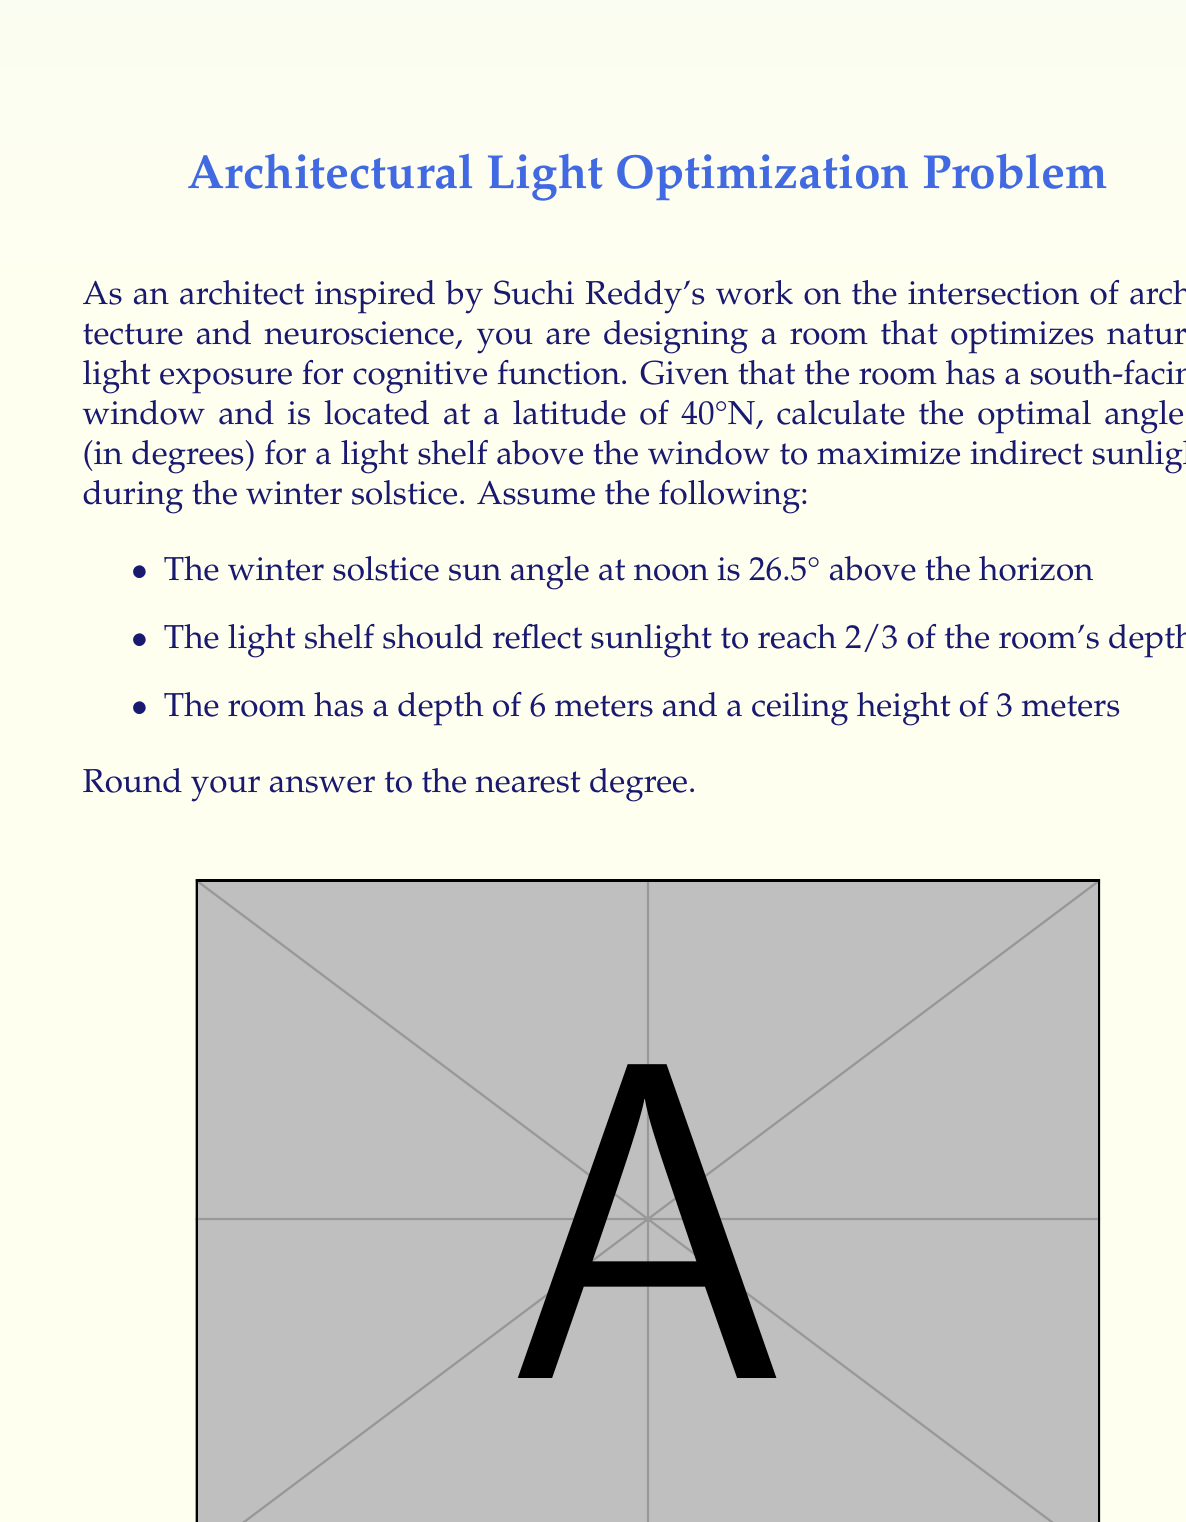Show me your answer to this math problem. To solve this problem, we'll follow these steps:

1) First, we need to determine the distance the light should travel from the light shelf to the target point in the room.

   The target point is 2/3 of the room's depth: $6m \times \frac{2}{3} = 4m$ from the window.

2) The height difference between the light shelf (at the top of the window) and the target point is:
   
   $3m - 1.5m = 1.5m$ (assuming the target is at mid-height of the room)

3) Now we can set up a right triangle where:
   - The adjacent side is 4m (horizontal distance)
   - The opposite side is 1.5m (vertical distance)

4) We need to find the angle this light ray makes with the horizontal. We can use the arctangent function:

   $\alpha = \arctan(\frac{1.5}{4}) \approx 20.56°$

5) The light shelf angle should bisect the angle between this ray and the incoming sunlight. The incoming sunlight angle is given as 26.5°.

6) Therefore, the optimal angle θ for the light shelf is:

   $\theta = \frac{26.5° + 20.56°}{2} \approx 23.53°$

7) Rounding to the nearest degree:

   $\theta \approx 24°$

This angle will ensure that the sunlight is reflected optimally to reach the desired depth of the room, maximizing natural light exposure which is crucial for cognitive function and aligns with the neuroscience-informed architectural approach inspired by Suchi Reddy's work.
Answer: The optimal angle θ for the light shelf is approximately 24°. 